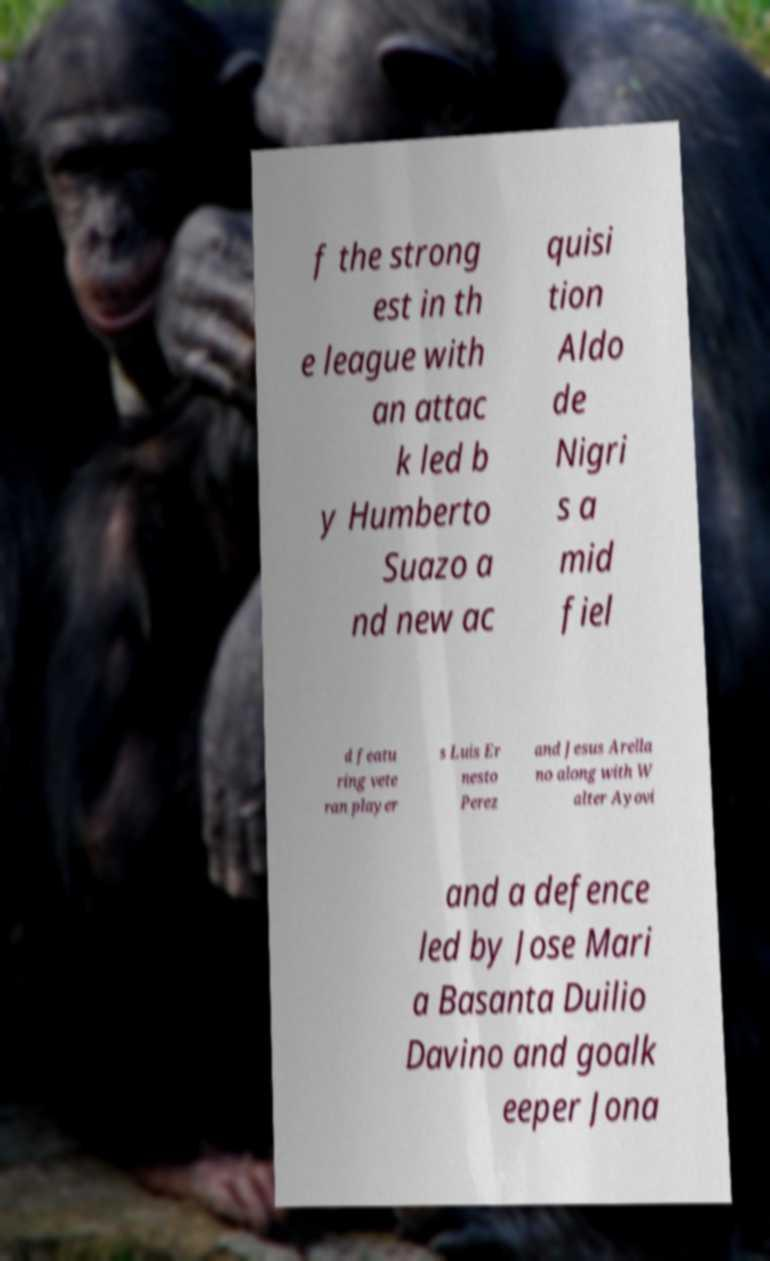Could you extract and type out the text from this image? f the strong est in th e league with an attac k led b y Humberto Suazo a nd new ac quisi tion Aldo de Nigri s a mid fiel d featu ring vete ran player s Luis Er nesto Perez and Jesus Arella no along with W alter Ayovi and a defence led by Jose Mari a Basanta Duilio Davino and goalk eeper Jona 